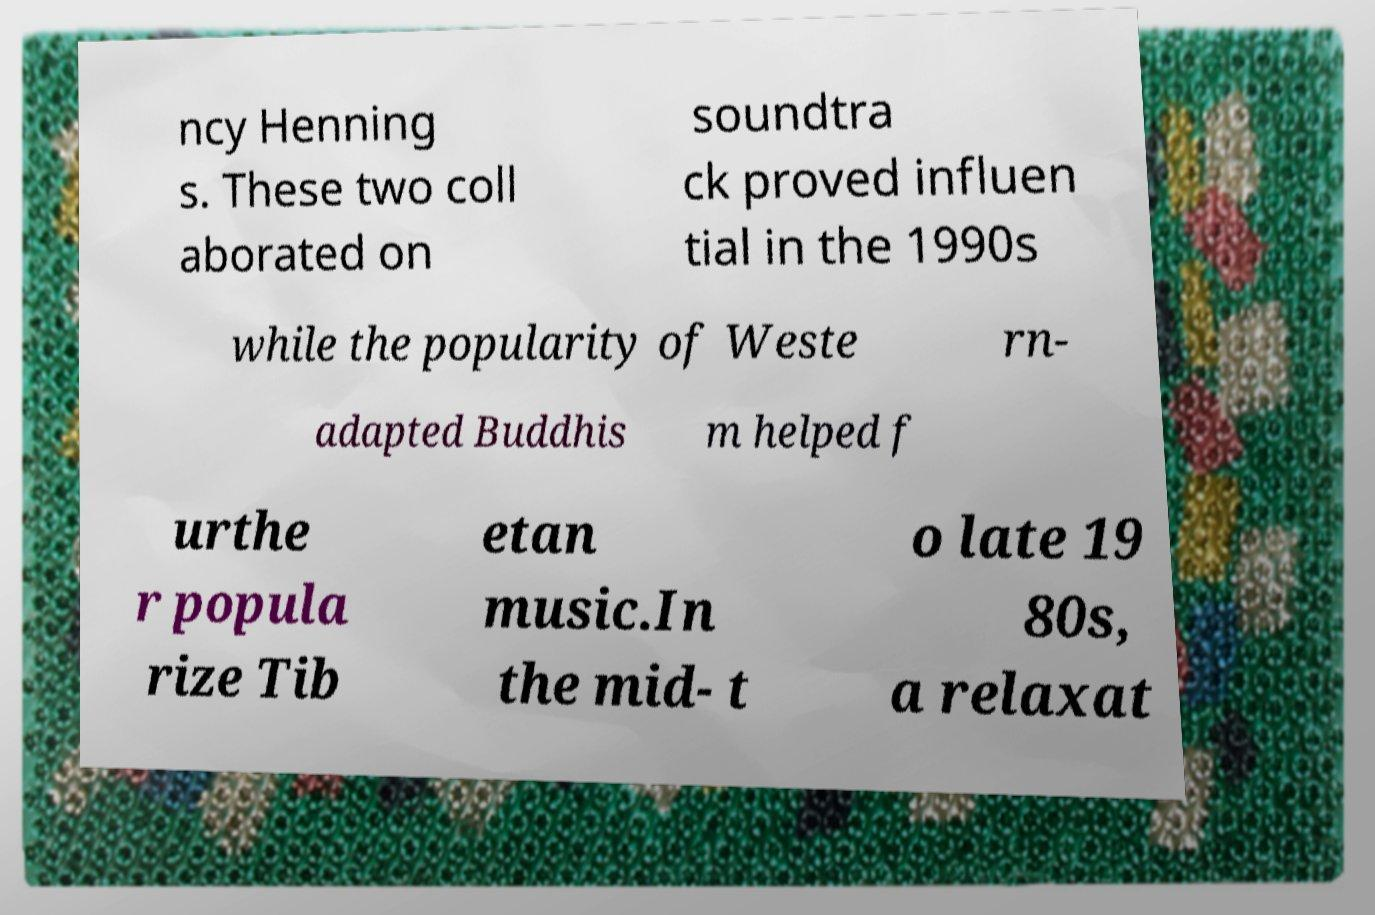There's text embedded in this image that I need extracted. Can you transcribe it verbatim? ncy Henning s. These two coll aborated on soundtra ck proved influen tial in the 1990s while the popularity of Weste rn- adapted Buddhis m helped f urthe r popula rize Tib etan music.In the mid- t o late 19 80s, a relaxat 